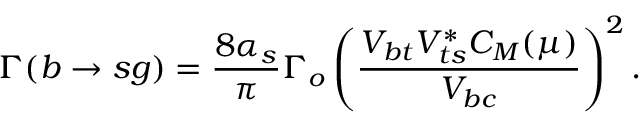Convert formula to latex. <formula><loc_0><loc_0><loc_500><loc_500>\Gamma ( b \rightarrow s g ) = \frac { 8 \alpha _ { s } } { \pi } \Gamma _ { o } \left ( \frac { V _ { b t } V _ { t s } ^ { * } C _ { M } ( \mu ) } { V _ { b c } } \right ) ^ { 2 } .</formula> 